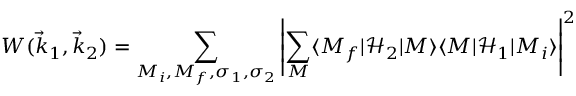Convert formula to latex. <formula><loc_0><loc_0><loc_500><loc_500>W ( { \vec { k } } _ { 1 } , { \vec { k } } _ { 2 } ) = \sum _ { M _ { i } , M _ { f } , \sigma _ { 1 } , \sigma _ { 2 } } \left | \sum _ { M } \langle M _ { f } | { \mathcal { H } } _ { 2 } | M \rangle \langle M | { \mathcal { H } } _ { 1 } | M _ { i } \rangle \right | ^ { 2 }</formula> 